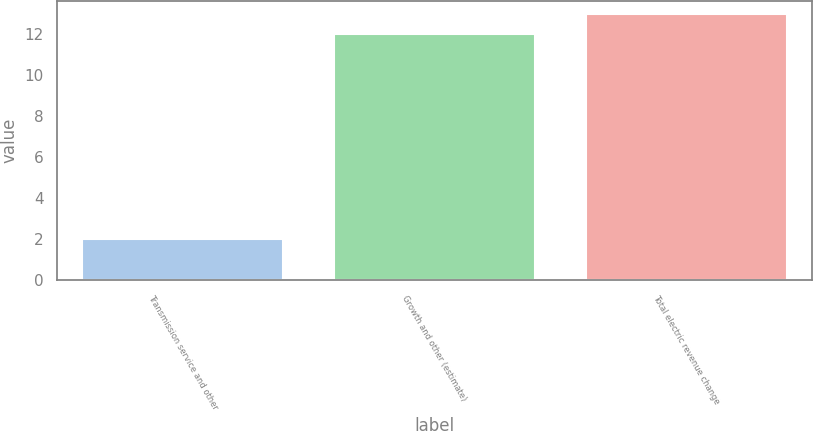Convert chart. <chart><loc_0><loc_0><loc_500><loc_500><bar_chart><fcel>Transmission service and other<fcel>Growth and other (estimate)<fcel>Total electric revenue change<nl><fcel>2<fcel>12<fcel>13<nl></chart> 